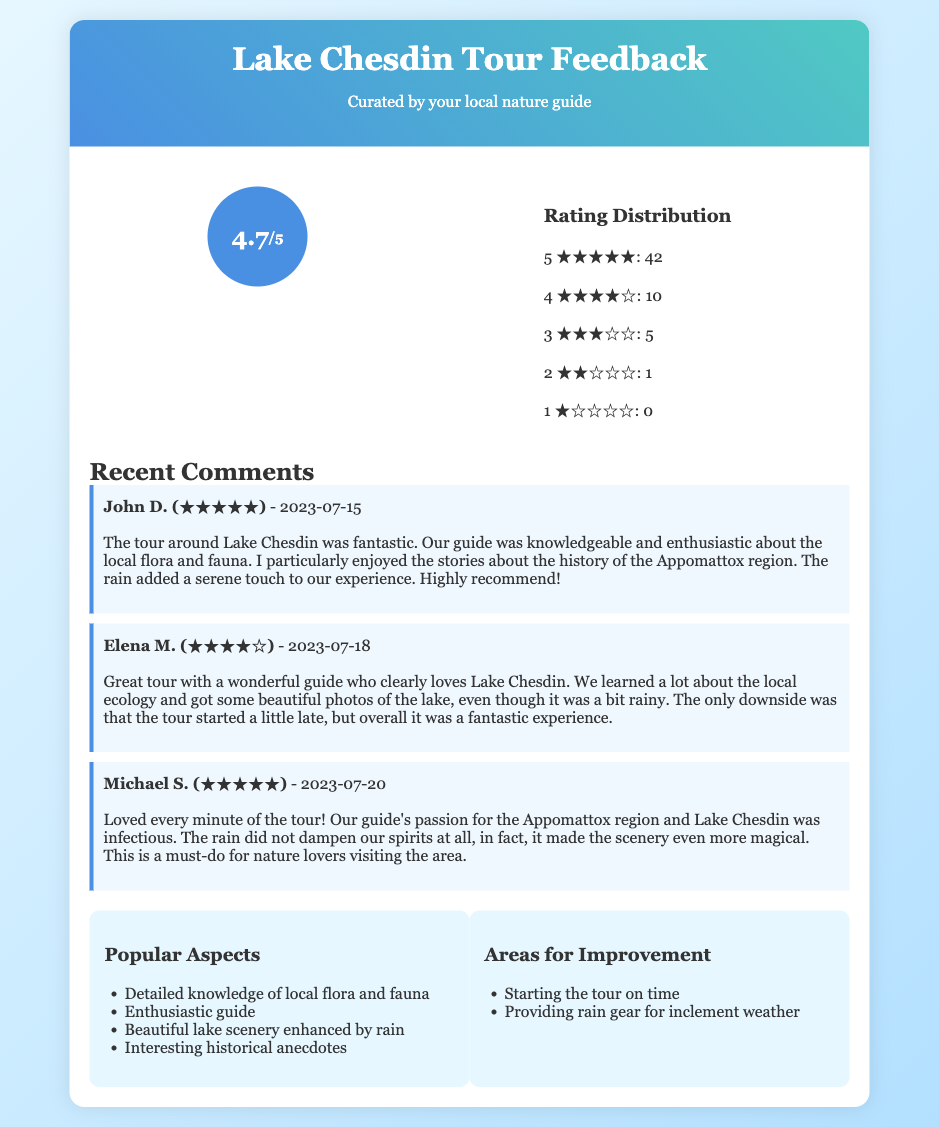What is the average rating of the tours? The average rating of the tours is found in the ratings section, which states 4.7 out of 5.
Answer: 4.7 How many 5-star ratings were given? The number of 5-star ratings is explicitly mentioned in the rating distribution, which is 42.
Answer: 42 Who left the comment with the highest rating? The comment with the highest rating belongs to John D., who rated it 5 stars.
Answer: John D What improvement is suggested for tour timing? The document mentions starting the tour on time as an area for improvement.
Answer: Starting the tour on time How did the rain affect the tour experience? Feedback indicated that the rain enhanced the scenery and did not dampen spirits, making it a positive aspect of the tour.
Answer: Enhanced the scenery What is one popular aspect of the tours? The document lists that a detailed knowledge of local flora and fauna is a popular aspect of the tours.
Answer: Detailed knowledge of local flora and fauna How many 4-star ratings were given? The number of 4-star ratings is recorded in the rating distribution, which is 10.
Answer: 10 What date did Michael S. leave his comment? The comment by Michael S. was left on July 20, 2023, as stated in his feedback.
Answer: 2023-07-20 What does the ticket primarily summarize? The ticket primarily summarizes visitor feedback from recent Lake Chesdin tours, including comments and ratings.
Answer: Visitor feedback from recent Lake Chesdin tours 